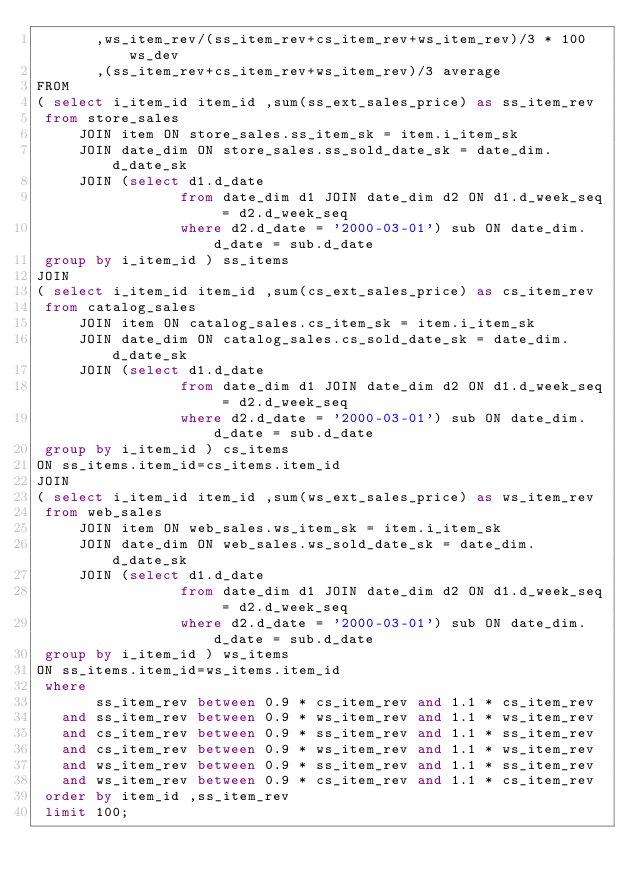<code> <loc_0><loc_0><loc_500><loc_500><_SQL_>       ,ws_item_rev/(ss_item_rev+cs_item_rev+ws_item_rev)/3 * 100 ws_dev
       ,(ss_item_rev+cs_item_rev+ws_item_rev)/3 average
FROM
( select i_item_id item_id ,sum(ss_ext_sales_price) as ss_item_rev
 from store_sales
     JOIN item ON store_sales.ss_item_sk = item.i_item_sk
     JOIN date_dim ON store_sales.ss_sold_date_sk = date_dim.d_date_sk
     JOIN (select d1.d_date
                 from date_dim d1 JOIN date_dim d2 ON d1.d_week_seq = d2.d_week_seq
                 where d2.d_date = '2000-03-01') sub ON date_dim.d_date = sub.d_date
 group by i_item_id ) ss_items
JOIN
( select i_item_id item_id ,sum(cs_ext_sales_price) as cs_item_rev
 from catalog_sales
     JOIN item ON catalog_sales.cs_item_sk = item.i_item_sk
     JOIN date_dim ON catalog_sales.cs_sold_date_sk = date_dim.d_date_sk
     JOIN (select d1.d_date
                 from date_dim d1 JOIN date_dim d2 ON d1.d_week_seq = d2.d_week_seq
                 where d2.d_date = '2000-03-01') sub ON date_dim.d_date = sub.d_date
 group by i_item_id ) cs_items
ON ss_items.item_id=cs_items.item_id
JOIN
( select i_item_id item_id ,sum(ws_ext_sales_price) as ws_item_rev
 from web_sales
     JOIN item ON web_sales.ws_item_sk = item.i_item_sk
     JOIN date_dim ON web_sales.ws_sold_date_sk = date_dim.d_date_sk
     JOIN (select d1.d_date
                 from date_dim d1 JOIN date_dim d2 ON d1.d_week_seq = d2.d_week_seq
                 where d2.d_date = '2000-03-01') sub ON date_dim.d_date = sub.d_date
 group by i_item_id ) ws_items
ON ss_items.item_id=ws_items.item_id
 where
       ss_item_rev between 0.9 * cs_item_rev and 1.1 * cs_item_rev
   and ss_item_rev between 0.9 * ws_item_rev and 1.1 * ws_item_rev
   and cs_item_rev between 0.9 * ss_item_rev and 1.1 * ss_item_rev
   and cs_item_rev between 0.9 * ws_item_rev and 1.1 * ws_item_rev
   and ws_item_rev between 0.9 * ss_item_rev and 1.1 * ss_item_rev
   and ws_item_rev between 0.9 * cs_item_rev and 1.1 * cs_item_rev
 order by item_id ,ss_item_rev
 limit 100;
</code> 